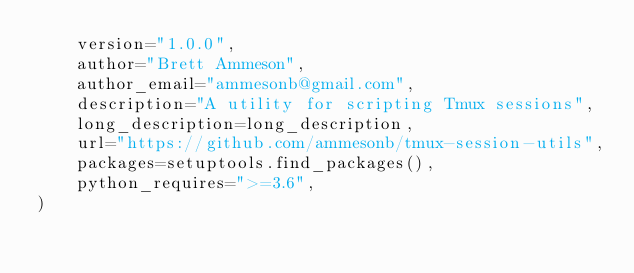<code> <loc_0><loc_0><loc_500><loc_500><_Python_>    version="1.0.0",
    author="Brett Ammeson",
    author_email="ammesonb@gmail.com",
    description="A utility for scripting Tmux sessions",
    long_description=long_description,
    url="https://github.com/ammesonb/tmux-session-utils",
    packages=setuptools.find_packages(),
    python_requires=">=3.6",
)
</code> 